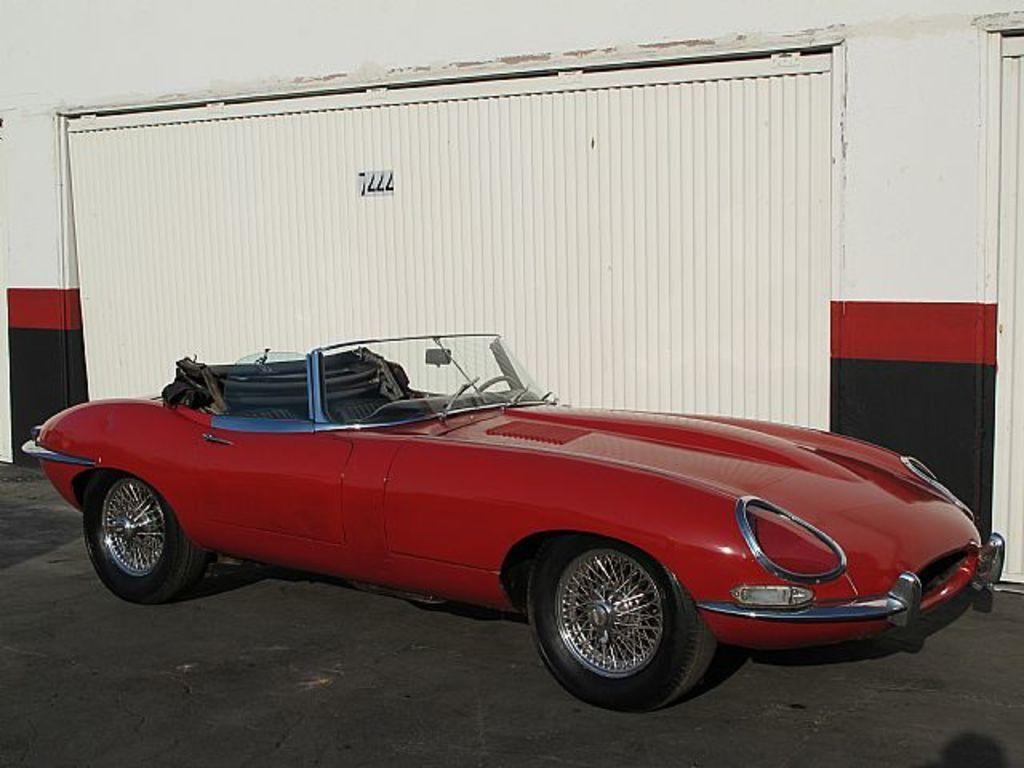Could you give a brief overview of what you see in this image? Here there is a red color car on the road. In the background there is a wall and shutter. 